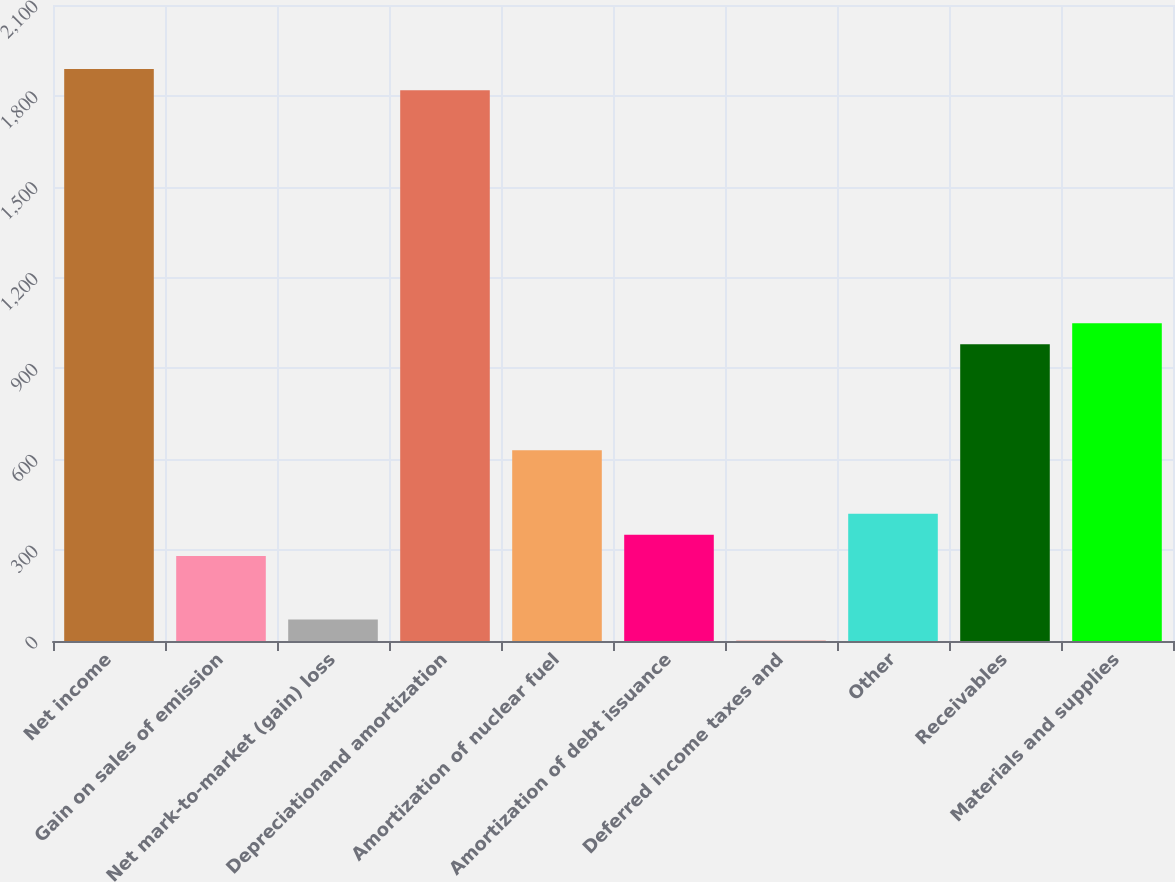Convert chart. <chart><loc_0><loc_0><loc_500><loc_500><bar_chart><fcel>Net income<fcel>Gain on sales of emission<fcel>Net mark-to-market (gain) loss<fcel>Depreciationand amortization<fcel>Amortization of nuclear fuel<fcel>Amortization of debt issuance<fcel>Deferred income taxes and<fcel>Other<fcel>Receivables<fcel>Materials and supplies<nl><fcel>1888.3<fcel>280.6<fcel>70.9<fcel>1818.4<fcel>630.1<fcel>350.5<fcel>1<fcel>420.4<fcel>979.6<fcel>1049.5<nl></chart> 